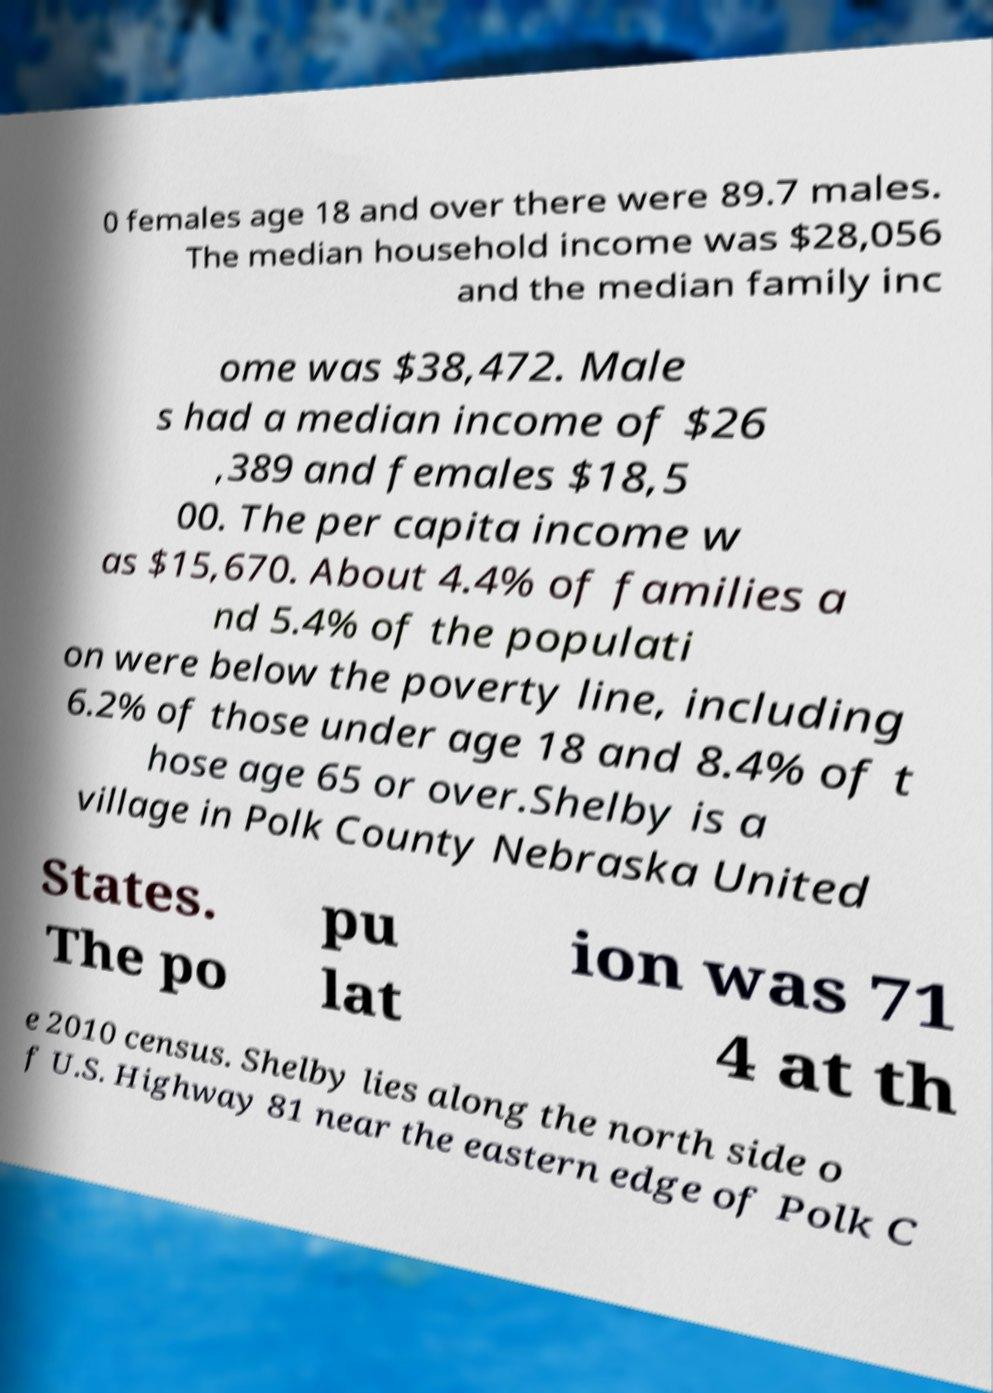Please identify and transcribe the text found in this image. 0 females age 18 and over there were 89.7 males. The median household income was $28,056 and the median family inc ome was $38,472. Male s had a median income of $26 ,389 and females $18,5 00. The per capita income w as $15,670. About 4.4% of families a nd 5.4% of the populati on were below the poverty line, including 6.2% of those under age 18 and 8.4% of t hose age 65 or over.Shelby is a village in Polk County Nebraska United States. The po pu lat ion was 71 4 at th e 2010 census. Shelby lies along the north side o f U.S. Highway 81 near the eastern edge of Polk C 